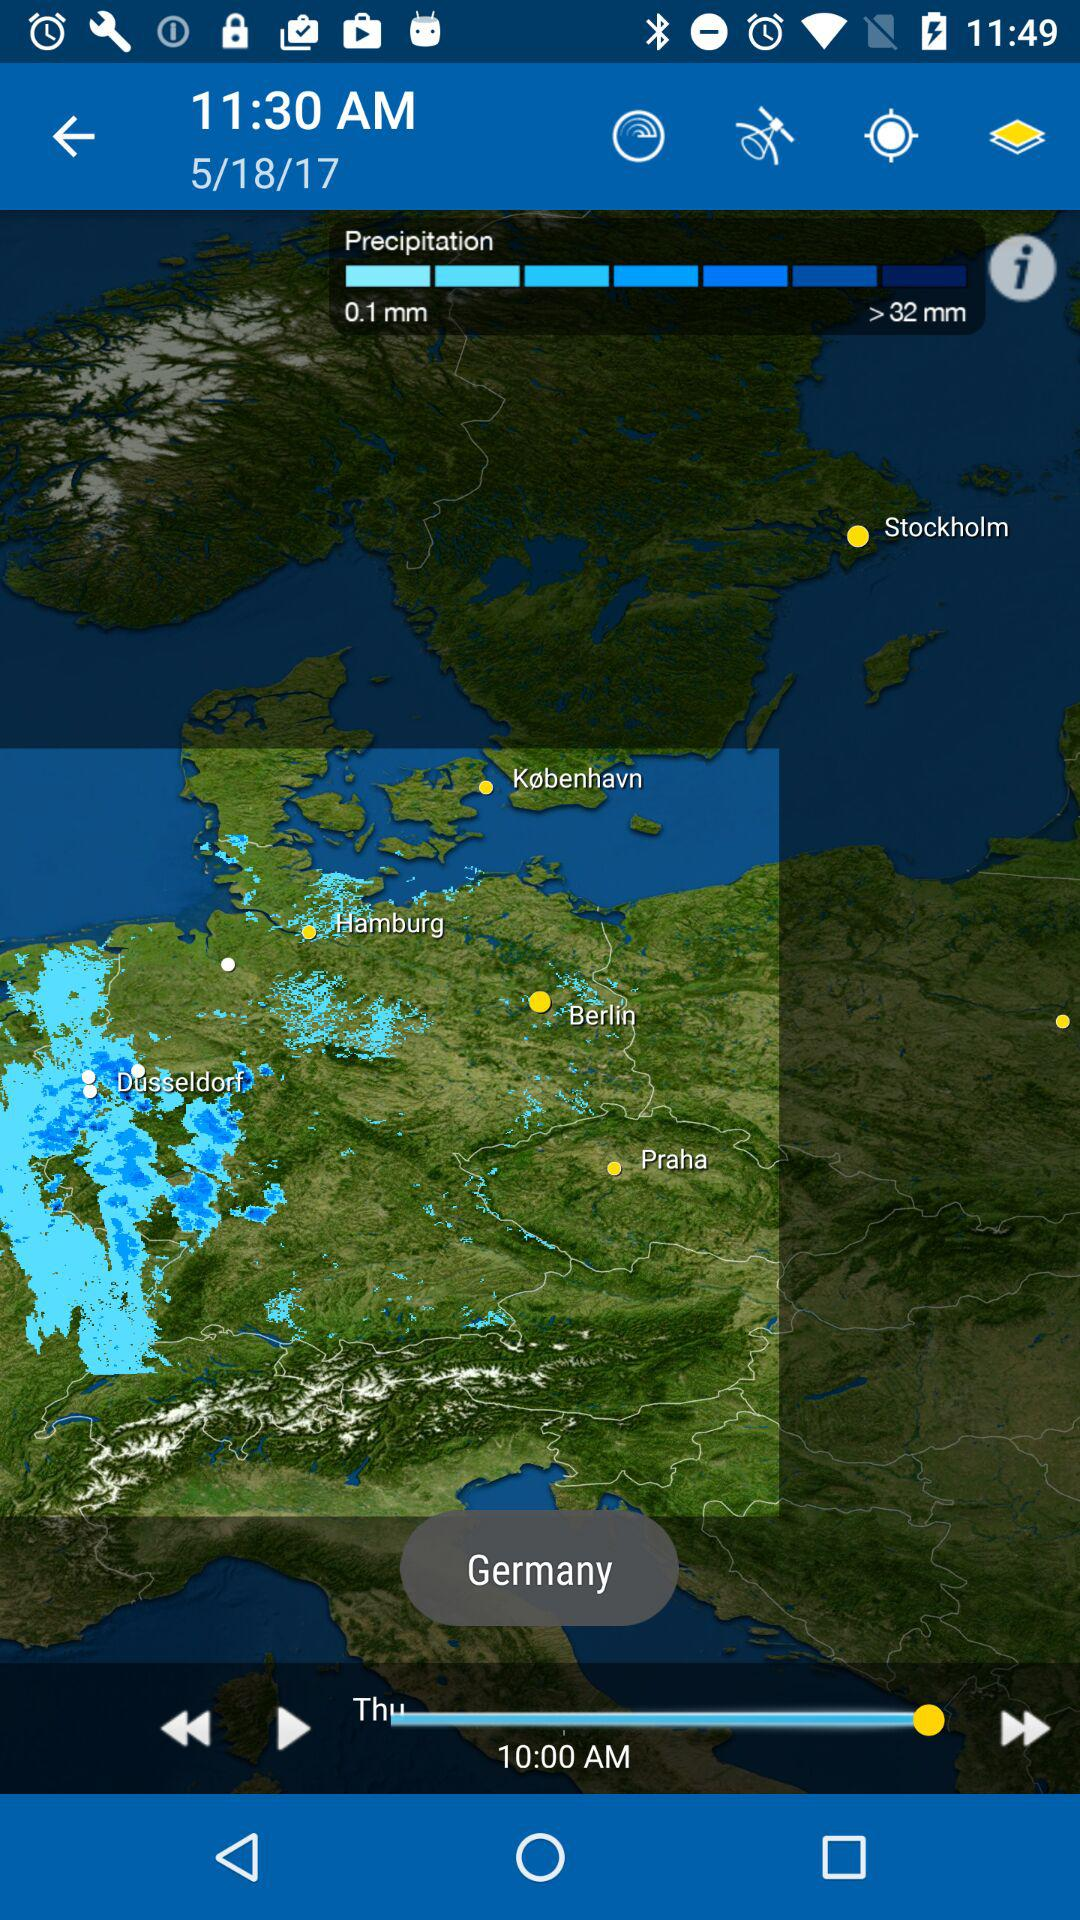What is the mentioned time? The mentioned times are 11:30 AM and 10:00 AM. 